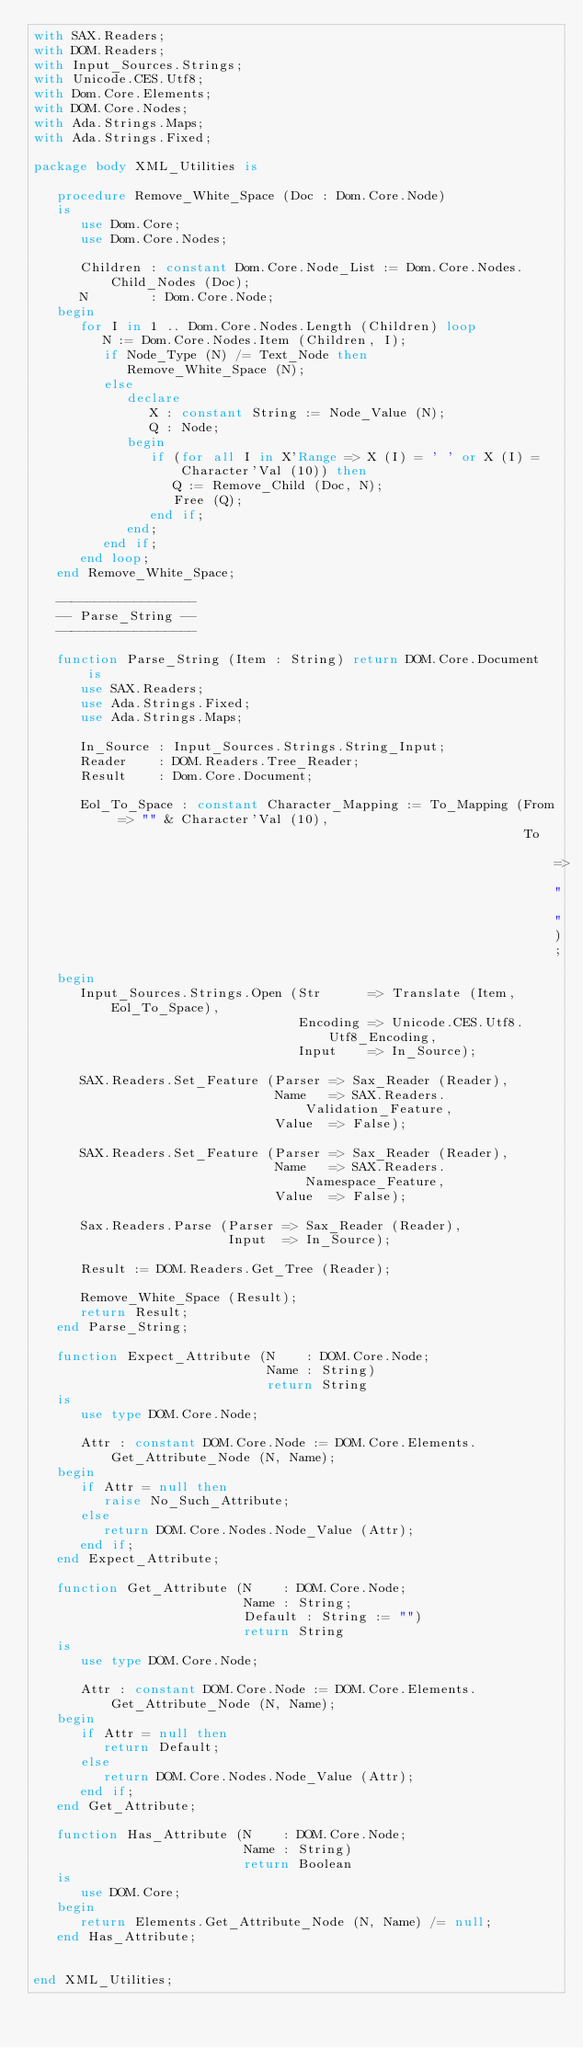Convert code to text. <code><loc_0><loc_0><loc_500><loc_500><_Ada_>with SAX.Readers;
with DOM.Readers;
with Input_Sources.Strings;
with Unicode.CES.Utf8;
with Dom.Core.Elements;
with DOM.Core.Nodes;
with Ada.Strings.Maps;
with Ada.Strings.Fixed;

package body XML_Utilities is

   procedure Remove_White_Space (Doc : Dom.Core.Node)
   is
      use Dom.Core;
      use Dom.Core.Nodes;

      Children : constant Dom.Core.Node_List := Dom.Core.Nodes.Child_Nodes (Doc);
      N        : Dom.Core.Node;
   begin
      for I in 1 .. Dom.Core.Nodes.Length (Children) loop
         N := Dom.Core.Nodes.Item (Children, I);
         if Node_Type (N) /= Text_Node then
            Remove_White_Space (N);
         else
            declare
               X : constant String := Node_Value (N);
               Q : Node;
            begin
               if (for all I in X'Range => X (I) = ' ' or X (I) = Character'Val (10)) then
                  Q := Remove_Child (Doc, N);
                  Free (Q);
               end if;
            end;
         end if;
      end loop;
   end Remove_White_Space;

   ------------------
   -- Parse_String --
   ------------------

   function Parse_String (Item : String) return DOM.Core.Document is
      use SAX.Readers;
      use Ada.Strings.Fixed;
      use Ada.Strings.Maps;

      In_Source : Input_Sources.Strings.String_Input;
      Reader    : DOM.Readers.Tree_Reader;
      Result    : Dom.Core.Document;

      Eol_To_Space : constant Character_Mapping := To_Mapping (From => "" & Character'Val (10),
                                                               To   => " ");
   begin
      Input_Sources.Strings.Open (Str      => Translate (Item, Eol_To_Space),
                                  Encoding => Unicode.CES.Utf8.Utf8_Encoding,
                                  Input    => In_Source);

      SAX.Readers.Set_Feature (Parser => Sax_Reader (Reader),
                               Name   => SAX.Readers.Validation_Feature,
                               Value  => False);

      SAX.Readers.Set_Feature (Parser => Sax_Reader (Reader),
                               Name   => SAX.Readers.Namespace_Feature,
                               Value  => False);

      Sax.Readers.Parse (Parser => Sax_Reader (Reader),
                         Input  => In_Source);

      Result := DOM.Readers.Get_Tree (Reader);

      Remove_White_Space (Result);
      return Result;
   end Parse_String;

   function Expect_Attribute (N    : DOM.Core.Node;
                              Name : String)
                              return String
   is
      use type DOM.Core.Node;

      Attr : constant DOM.Core.Node := DOM.Core.Elements.Get_Attribute_Node (N, Name);
   begin
      if Attr = null then
         raise No_Such_Attribute;
      else
         return DOM.Core.Nodes.Node_Value (Attr);
      end if;
   end Expect_Attribute;

   function Get_Attribute (N    : DOM.Core.Node;
                           Name : String;
                           Default : String := "")
                           return String
   is
      use type DOM.Core.Node;

      Attr : constant DOM.Core.Node := DOM.Core.Elements.Get_Attribute_Node (N, Name);
   begin
      if Attr = null then
         return Default;
      else
         return DOM.Core.Nodes.Node_Value (Attr);
      end if;
   end Get_Attribute;

   function Has_Attribute (N    : DOM.Core.Node;
                           Name : String)
                           return Boolean
   is
      use DOM.Core;
   begin
      return Elements.Get_Attribute_Node (N, Name) /= null;
   end Has_Attribute;


end XML_Utilities;
</code> 